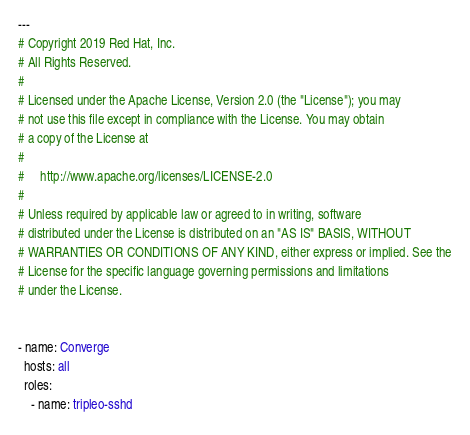Convert code to text. <code><loc_0><loc_0><loc_500><loc_500><_YAML_>---
# Copyright 2019 Red Hat, Inc.
# All Rights Reserved.
#
# Licensed under the Apache License, Version 2.0 (the "License"); you may
# not use this file except in compliance with the License. You may obtain
# a copy of the License at
#
#     http://www.apache.org/licenses/LICENSE-2.0
#
# Unless required by applicable law or agreed to in writing, software
# distributed under the License is distributed on an "AS IS" BASIS, WITHOUT
# WARRANTIES OR CONDITIONS OF ANY KIND, either express or implied. See the
# License for the specific language governing permissions and limitations
# under the License.


- name: Converge
  hosts: all
  roles:
    - name: tripleo-sshd
</code> 